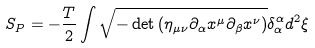<formula> <loc_0><loc_0><loc_500><loc_500>S _ { P } = - \frac { T } { 2 } \int \sqrt { - \det \left ( \eta _ { \mu \nu } \partial _ { \alpha } x ^ { \mu } \partial _ { \beta } x ^ { \nu } \right ) } \delta _ { \alpha } ^ { \alpha } d ^ { 2 } \xi</formula> 